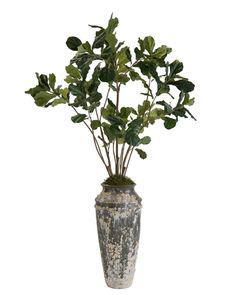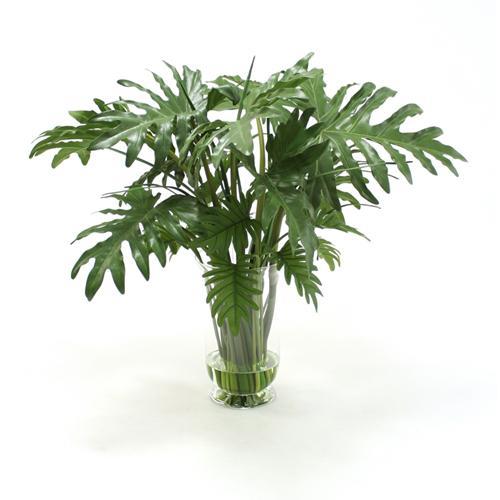The first image is the image on the left, the second image is the image on the right. Evaluate the accuracy of this statement regarding the images: "One vase is tall, opaque and solid-colored with a ribbed surface, and the other vase is shorter and black in color.". Is it true? Answer yes or no. No. The first image is the image on the left, the second image is the image on the right. Assess this claim about the two images: "At least one vase is clear glass.". Correct or not? Answer yes or no. Yes. 